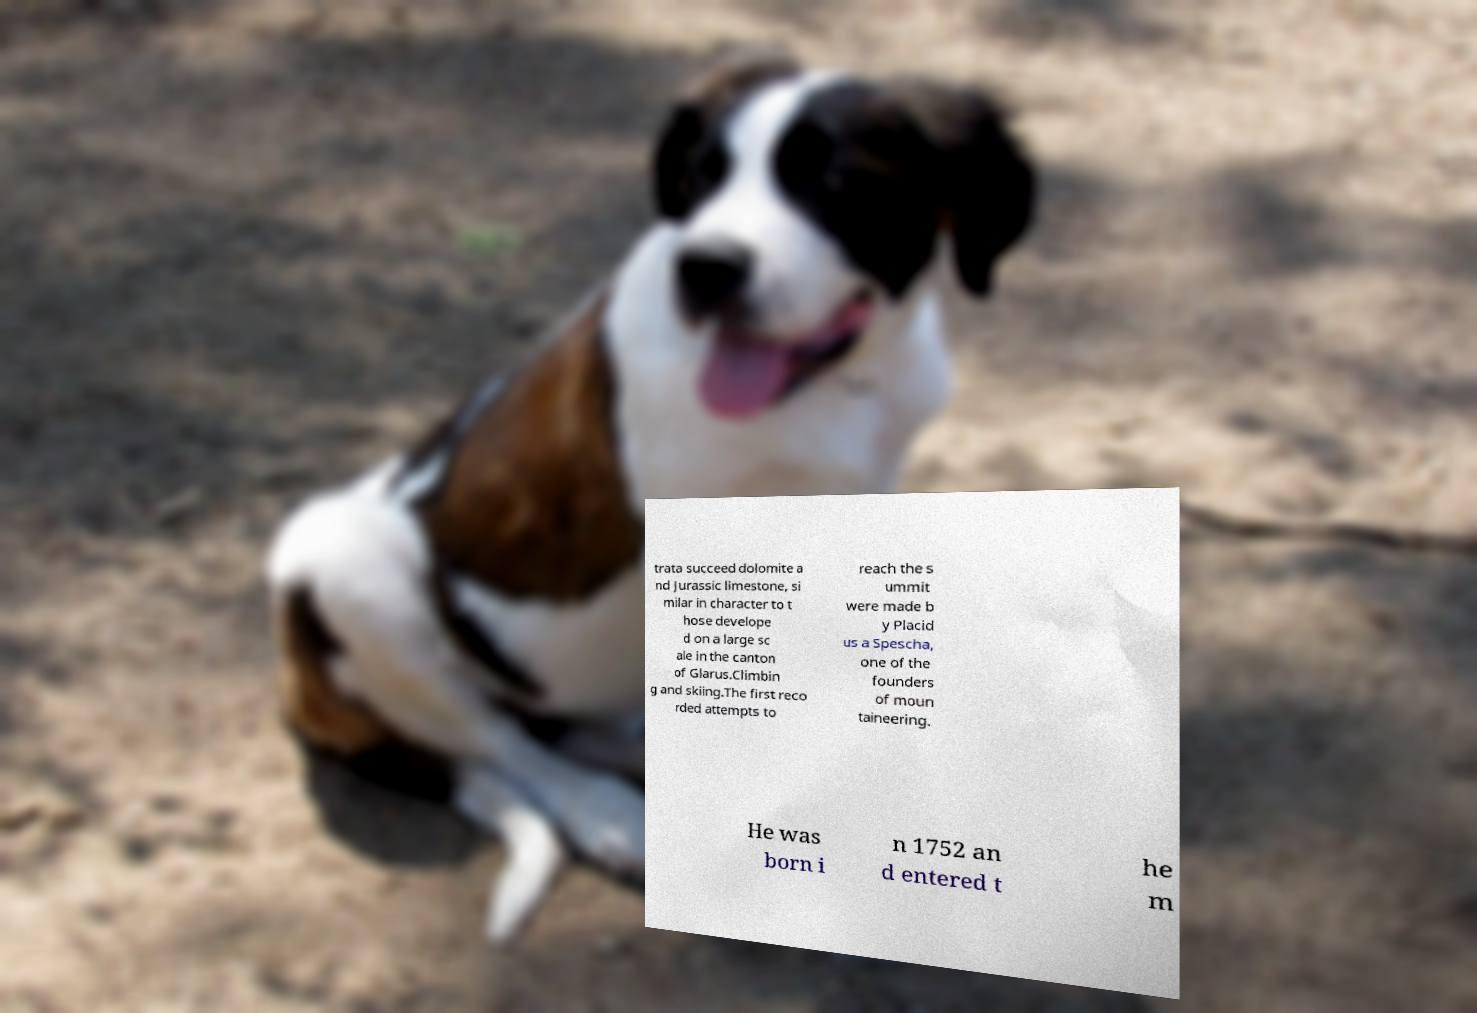Please identify and transcribe the text found in this image. trata succeed dolomite a nd Jurassic limestone, si milar in character to t hose develope d on a large sc ale in the canton of Glarus.Climbin g and skiing.The first reco rded attempts to reach the s ummit were made b y Placid us a Spescha, one of the founders of moun taineering. He was born i n 1752 an d entered t he m 